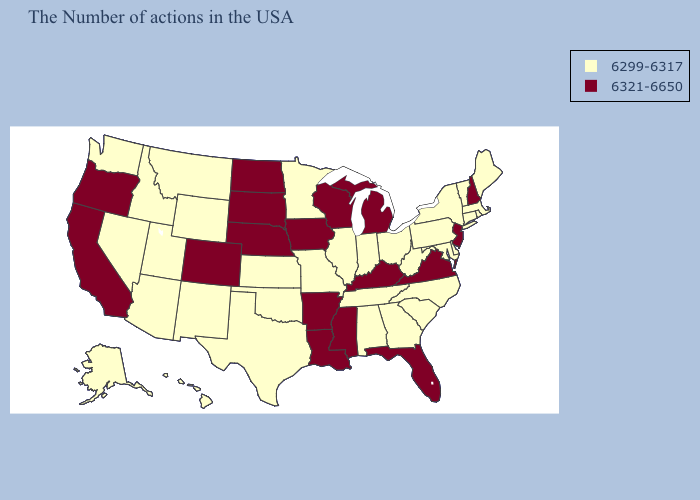What is the value of Arkansas?
Be succinct. 6321-6650. Does Florida have the highest value in the USA?
Give a very brief answer. Yes. What is the lowest value in the USA?
Be succinct. 6299-6317. What is the lowest value in states that border Michigan?
Quick response, please. 6299-6317. What is the value of Oklahoma?
Give a very brief answer. 6299-6317. Does the map have missing data?
Answer briefly. No. How many symbols are there in the legend?
Short answer required. 2. What is the value of Hawaii?
Short answer required. 6299-6317. Name the states that have a value in the range 6299-6317?
Answer briefly. Maine, Massachusetts, Rhode Island, Vermont, Connecticut, New York, Delaware, Maryland, Pennsylvania, North Carolina, South Carolina, West Virginia, Ohio, Georgia, Indiana, Alabama, Tennessee, Illinois, Missouri, Minnesota, Kansas, Oklahoma, Texas, Wyoming, New Mexico, Utah, Montana, Arizona, Idaho, Nevada, Washington, Alaska, Hawaii. Which states have the lowest value in the USA?
Short answer required. Maine, Massachusetts, Rhode Island, Vermont, Connecticut, New York, Delaware, Maryland, Pennsylvania, North Carolina, South Carolina, West Virginia, Ohio, Georgia, Indiana, Alabama, Tennessee, Illinois, Missouri, Minnesota, Kansas, Oklahoma, Texas, Wyoming, New Mexico, Utah, Montana, Arizona, Idaho, Nevada, Washington, Alaska, Hawaii. Which states have the lowest value in the MidWest?
Answer briefly. Ohio, Indiana, Illinois, Missouri, Minnesota, Kansas. Does the map have missing data?
Concise answer only. No. Name the states that have a value in the range 6299-6317?
Answer briefly. Maine, Massachusetts, Rhode Island, Vermont, Connecticut, New York, Delaware, Maryland, Pennsylvania, North Carolina, South Carolina, West Virginia, Ohio, Georgia, Indiana, Alabama, Tennessee, Illinois, Missouri, Minnesota, Kansas, Oklahoma, Texas, Wyoming, New Mexico, Utah, Montana, Arizona, Idaho, Nevada, Washington, Alaska, Hawaii. Which states have the lowest value in the Northeast?
Keep it brief. Maine, Massachusetts, Rhode Island, Vermont, Connecticut, New York, Pennsylvania. What is the lowest value in the USA?
Keep it brief. 6299-6317. 